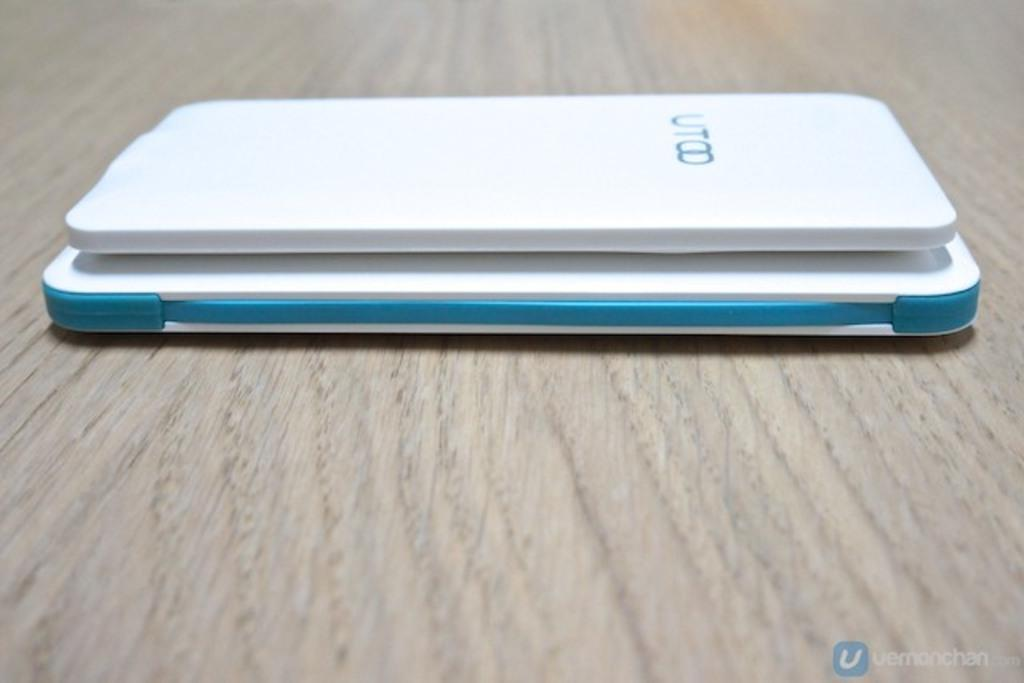Provide a one-sentence caption for the provided image. A blue and white UT00 device sits on a table. 